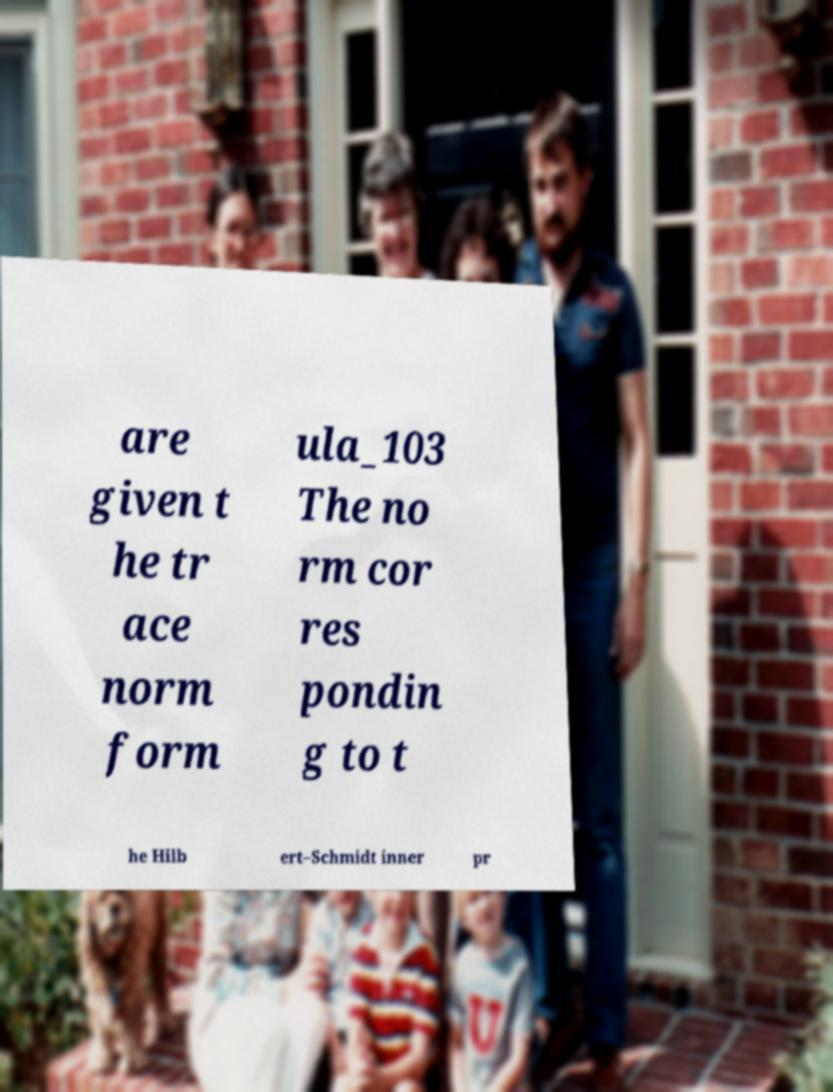Can you accurately transcribe the text from the provided image for me? are given t he tr ace norm form ula_103 The no rm cor res pondin g to t he Hilb ert–Schmidt inner pr 